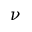Convert formula to latex. <formula><loc_0><loc_0><loc_500><loc_500>\nu</formula> 